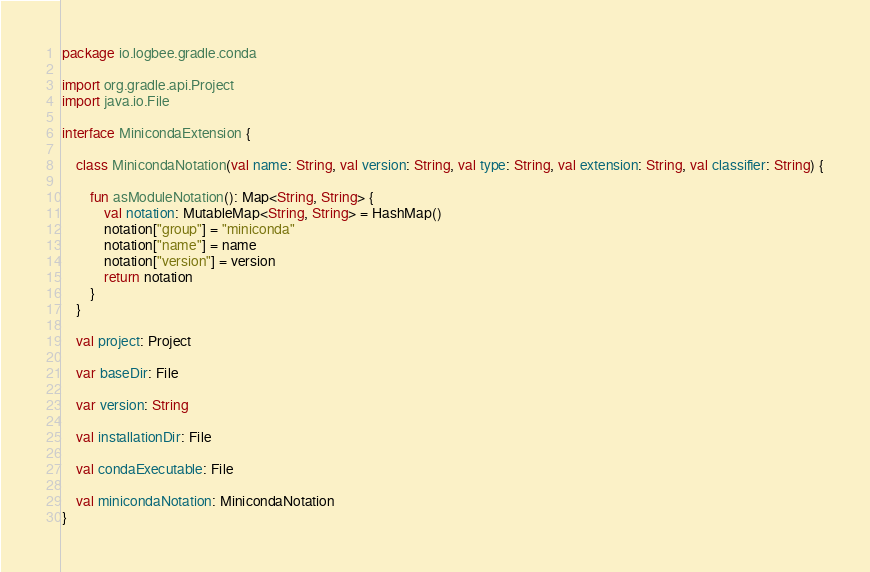Convert code to text. <code><loc_0><loc_0><loc_500><loc_500><_Kotlin_>package io.logbee.gradle.conda

import org.gradle.api.Project
import java.io.File

interface MinicondaExtension {

    class MinicondaNotation(val name: String, val version: String, val type: String, val extension: String, val classifier: String) {

        fun asModuleNotation(): Map<String, String> {
            val notation: MutableMap<String, String> = HashMap()
            notation["group"] = "miniconda"
            notation["name"] = name
            notation["version"] = version
            return notation
        }
    }

    val project: Project

    var baseDir: File

    var version: String

    val installationDir: File

    val condaExecutable: File

    val minicondaNotation: MinicondaNotation
}</code> 